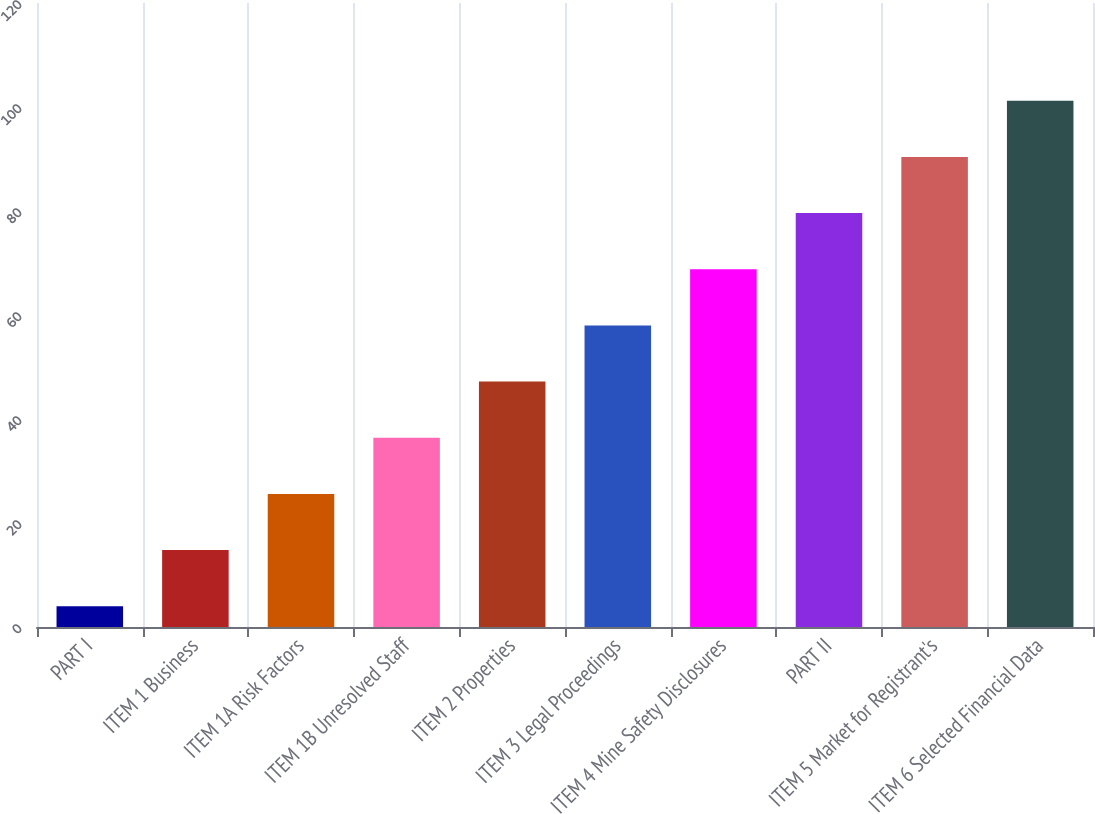Convert chart to OTSL. <chart><loc_0><loc_0><loc_500><loc_500><bar_chart><fcel>PART I<fcel>ITEM 1 Business<fcel>ITEM 1A Risk Factors<fcel>ITEM 1B Unresolved Staff<fcel>ITEM 2 Properties<fcel>ITEM 3 Legal Proceedings<fcel>ITEM 4 Mine Safety Disclosures<fcel>PART II<fcel>ITEM 5 Market for Registrant's<fcel>ITEM 6 Selected Financial Data<nl><fcel>4<fcel>14.8<fcel>25.6<fcel>36.4<fcel>47.2<fcel>58<fcel>68.8<fcel>79.6<fcel>90.4<fcel>101.2<nl></chart> 